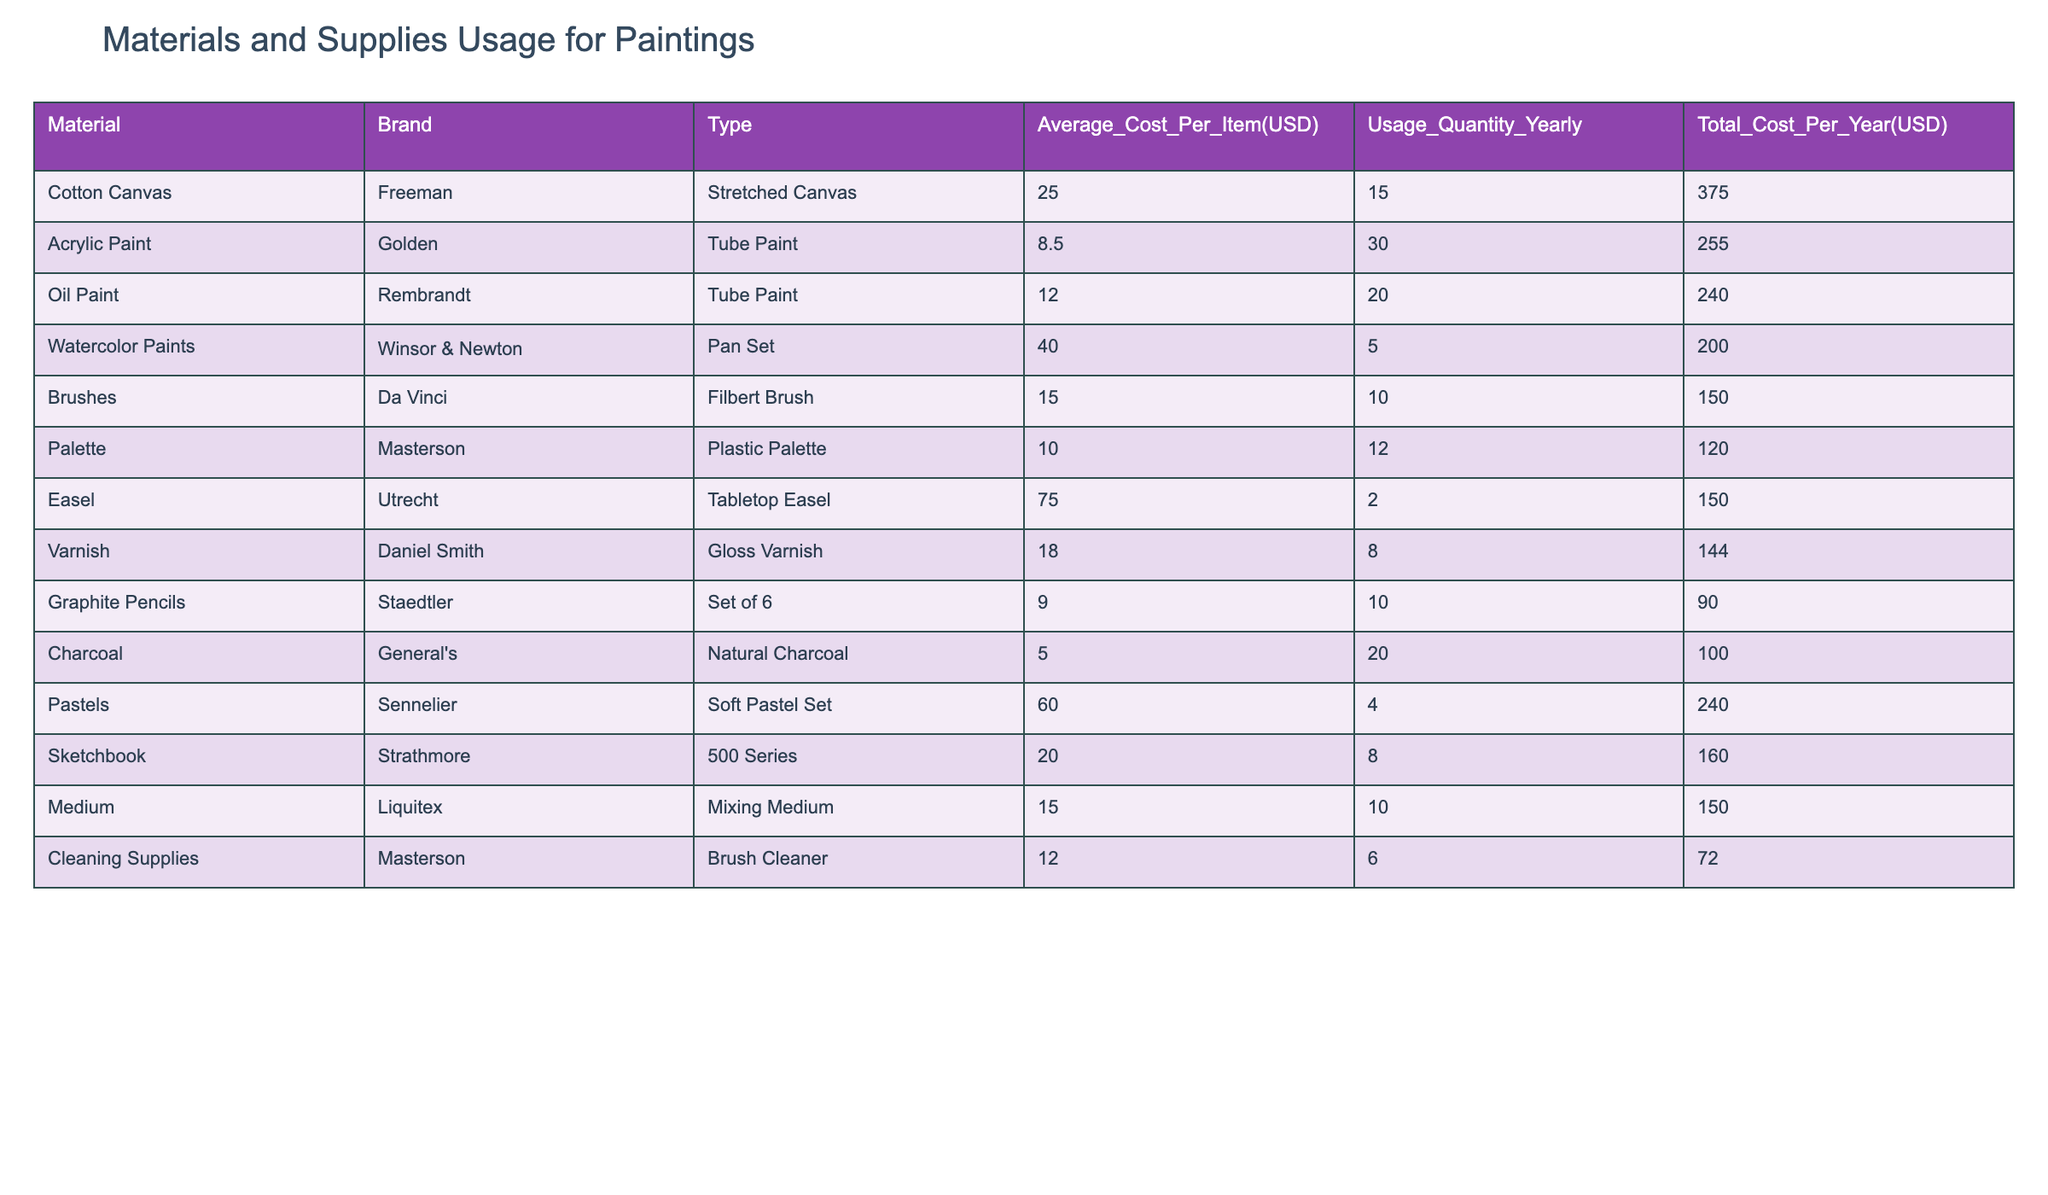What is the total cost for Cotton Canvas? The total cost for Cotton Canvas is listed in the table as 375.00 USD.
Answer: 375.00 USD How many more tubes of Acrylic Paint were used compared to Oil Paint? Acrylic Paint usage is 30 tubes and Oil Paint usage is 20 tubes. The difference is 30 - 20 = 10 tubes.
Answer: 10 tubes Is the Average Cost Per Item for Varnish greater than that for Brushes? The Average Cost Per Item for Varnish is 18.00 USD, while for Brushes it is 15.00 USD. Since 18.00 > 15.00, the statement is true.
Answer: Yes What is the total yearly cost for all types of paint combined? The total yearly costs for each paint are: Acrylic Paint 255.00 USD, Oil Paint 240.00 USD, Watercolor Paints 200.00 USD, Pastels 240.00 USD. Adding these: 255 + 240 + 200 + 240 = 935.00 USD.
Answer: 935.00 USD Which material has the highest usage quantity yearly? Reviewing the table, Acrylic Paint has the highest usage quantity of 30 tubes compared to others like Cotton Canvas (15) and Oil Paint (20).
Answer: Acrylic Paint What is the average cost of all painting materials listed? The total cost for all materials is 2,103.00 USD (375 + 255 + 240 + 200 + 150 + 120 + 150 + 144 + 90 + 100 + 240 + 160 + 150 + 72). There are 14 materials. Thus, the average cost is 2,103 / 14 = 150.21 USD.
Answer: 150.21 USD Are there more instances of cheaper materials (costing less than 15 USD) than expensive materials (costing 15 USD or more)? The materials with a cost under 15 USD are Charcoal (5.00 USD) and Graphite Pencils (9.00 USD) totaling 2. The materials with a cost of 15 USD or more are 12. Hence, there are fewer cheaper materials than expensive ones.
Answer: No What is the total cost of all cleaning supplies? The table shows that the total cost for cleaning supplies (Brush Cleaner) is 72.00 USD.
Answer: 72.00 USD How much more did you spend on Medium compared to Cleaning Supplies? The total cost for Medium is 150.00 USD, while Cleaning Supplies cost 72.00 USD. Therefore, the difference is 150 - 72 = 78.00 USD.
Answer: 78.00 USD 